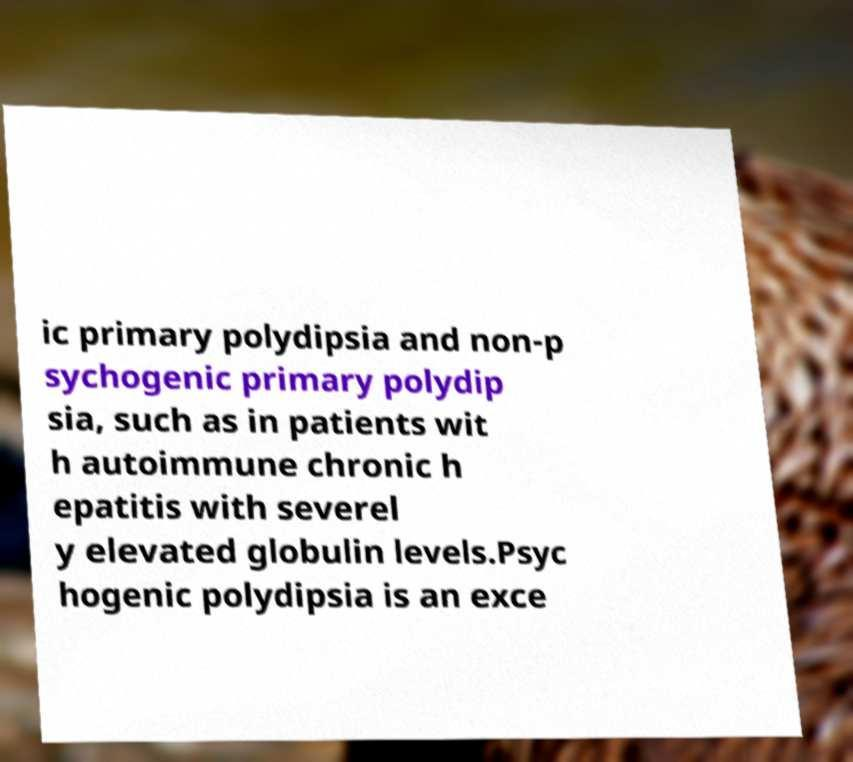I need the written content from this picture converted into text. Can you do that? ic primary polydipsia and non-p sychogenic primary polydip sia, such as in patients wit h autoimmune chronic h epatitis with severel y elevated globulin levels.Psyc hogenic polydipsia is an exce 